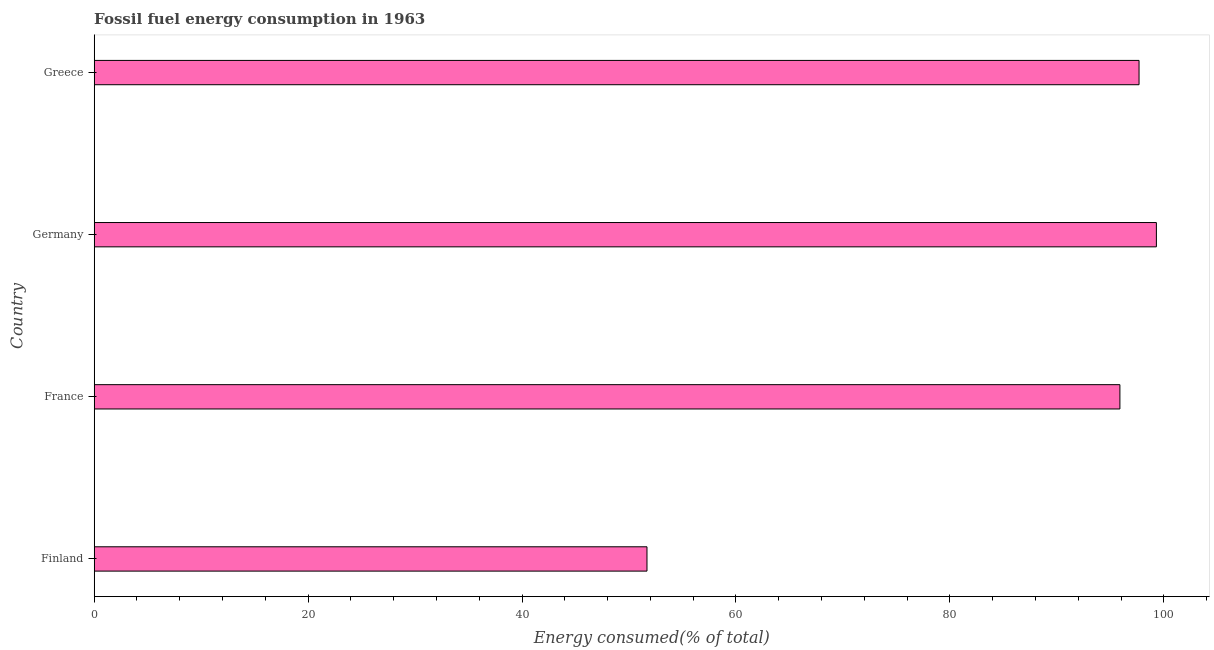Does the graph contain any zero values?
Provide a succinct answer. No. Does the graph contain grids?
Your answer should be compact. No. What is the title of the graph?
Make the answer very short. Fossil fuel energy consumption in 1963. What is the label or title of the X-axis?
Make the answer very short. Energy consumed(% of total). What is the label or title of the Y-axis?
Keep it short and to the point. Country. What is the fossil fuel energy consumption in Greece?
Keep it short and to the point. 97.68. Across all countries, what is the maximum fossil fuel energy consumption?
Your answer should be compact. 99.3. Across all countries, what is the minimum fossil fuel energy consumption?
Make the answer very short. 51.68. In which country was the fossil fuel energy consumption minimum?
Offer a terse response. Finland. What is the sum of the fossil fuel energy consumption?
Your answer should be very brief. 344.55. What is the difference between the fossil fuel energy consumption in France and Germany?
Ensure brevity in your answer.  -3.41. What is the average fossil fuel energy consumption per country?
Your answer should be very brief. 86.14. What is the median fossil fuel energy consumption?
Give a very brief answer. 96.79. In how many countries, is the fossil fuel energy consumption greater than 60 %?
Provide a succinct answer. 3. Is the fossil fuel energy consumption in France less than that in Greece?
Your answer should be compact. Yes. Is the difference between the fossil fuel energy consumption in France and Germany greater than the difference between any two countries?
Your response must be concise. No. What is the difference between the highest and the second highest fossil fuel energy consumption?
Provide a succinct answer. 1.62. Is the sum of the fossil fuel energy consumption in Finland and Germany greater than the maximum fossil fuel energy consumption across all countries?
Your response must be concise. Yes. What is the difference between the highest and the lowest fossil fuel energy consumption?
Provide a short and direct response. 47.62. How many bars are there?
Provide a succinct answer. 4. Are all the bars in the graph horizontal?
Your response must be concise. Yes. What is the difference between two consecutive major ticks on the X-axis?
Make the answer very short. 20. Are the values on the major ticks of X-axis written in scientific E-notation?
Offer a very short reply. No. What is the Energy consumed(% of total) in Finland?
Give a very brief answer. 51.68. What is the Energy consumed(% of total) of France?
Provide a succinct answer. 95.89. What is the Energy consumed(% of total) of Germany?
Make the answer very short. 99.3. What is the Energy consumed(% of total) of Greece?
Provide a short and direct response. 97.68. What is the difference between the Energy consumed(% of total) in Finland and France?
Your answer should be compact. -44.21. What is the difference between the Energy consumed(% of total) in Finland and Germany?
Provide a short and direct response. -47.62. What is the difference between the Energy consumed(% of total) in Finland and Greece?
Your response must be concise. -46. What is the difference between the Energy consumed(% of total) in France and Germany?
Provide a short and direct response. -3.41. What is the difference between the Energy consumed(% of total) in France and Greece?
Offer a very short reply. -1.79. What is the difference between the Energy consumed(% of total) in Germany and Greece?
Your answer should be compact. 1.62. What is the ratio of the Energy consumed(% of total) in Finland to that in France?
Provide a succinct answer. 0.54. What is the ratio of the Energy consumed(% of total) in Finland to that in Germany?
Provide a succinct answer. 0.52. What is the ratio of the Energy consumed(% of total) in Finland to that in Greece?
Offer a terse response. 0.53. What is the ratio of the Energy consumed(% of total) in France to that in Germany?
Provide a succinct answer. 0.97. What is the ratio of the Energy consumed(% of total) in France to that in Greece?
Make the answer very short. 0.98. What is the ratio of the Energy consumed(% of total) in Germany to that in Greece?
Offer a very short reply. 1.02. 